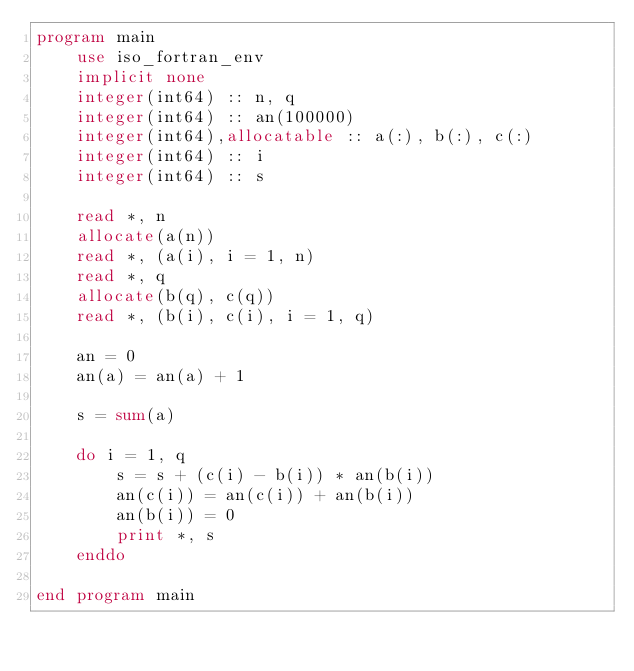<code> <loc_0><loc_0><loc_500><loc_500><_FORTRAN_>program main
    use iso_fortran_env
    implicit none
    integer(int64) :: n, q
    integer(int64) :: an(100000)
    integer(int64),allocatable :: a(:), b(:), c(:)
    integer(int64) :: i
    integer(int64) :: s

    read *, n
    allocate(a(n))
    read *, (a(i), i = 1, n)
    read *, q
    allocate(b(q), c(q))
    read *, (b(i), c(i), i = 1, q)

    an = 0
    an(a) = an(a) + 1

    s = sum(a)

    do i = 1, q
        s = s + (c(i) - b(i)) * an(b(i))
        an(c(i)) = an(c(i)) + an(b(i))
        an(b(i)) = 0
        print *, s
    enddo

end program main</code> 